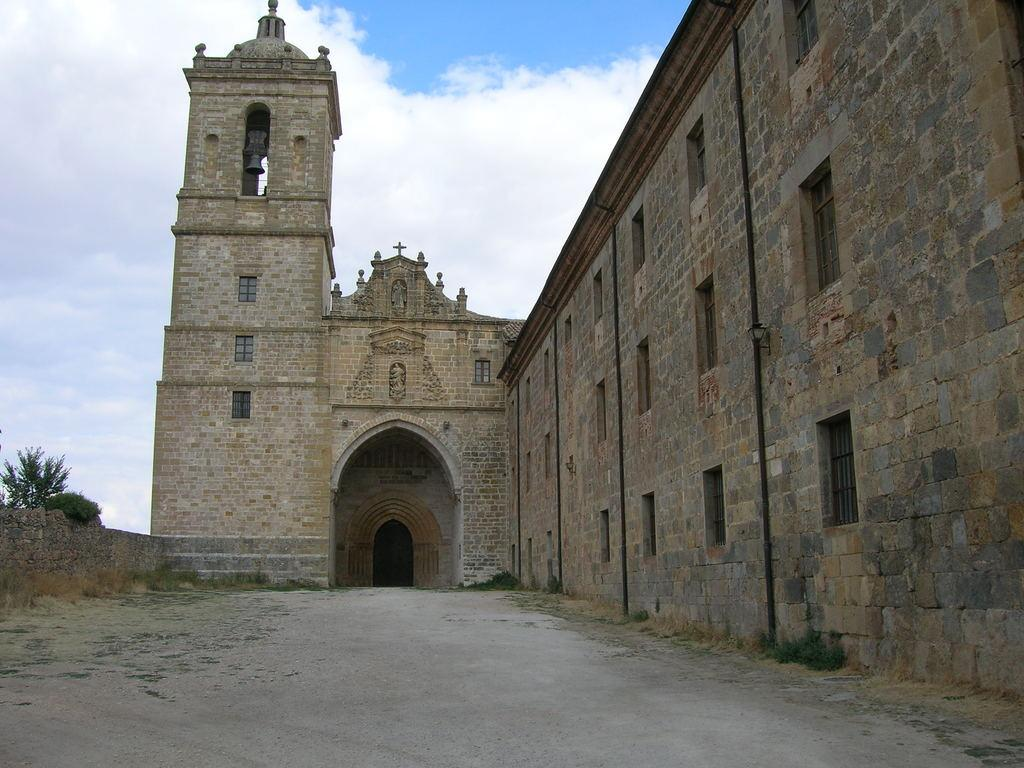What type of structure is present in the image? There is a building in the image. What is the color of the building? The building is brown in color. What other natural elements can be seen in the image? There are trees in the image. What is the color of the trees? The trees are green in color. What is visible in the background of the image? The sky is visible in the image. What colors can be seen in the sky? The sky has both white and blue colors. Can you see a pencil fight happening in the image? There is no pencil fight present in the image. What type of rail is visible in the image? There is no rail present in the image. 